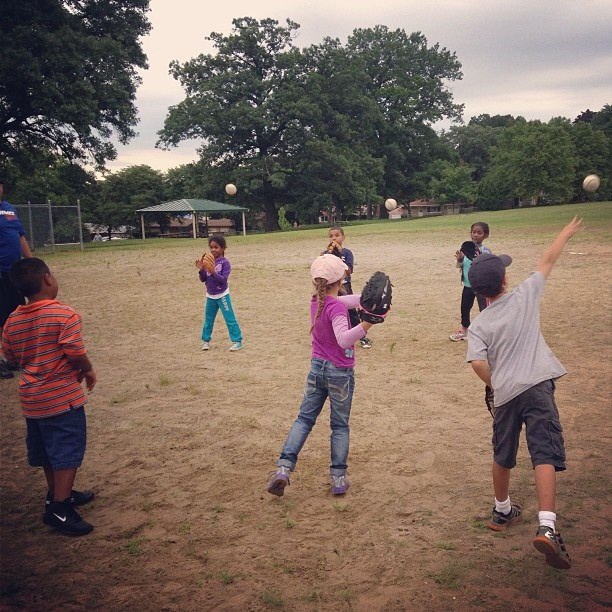Describe the objects in this image and their specific colors. I can see people in black, darkgray, gray, and brown tones, people in black, maroon, brown, and gray tones, people in black, gray, lightpink, and darkgray tones, people in black, teal, darkgray, and purple tones, and people in black, navy, brown, and maroon tones in this image. 